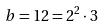<formula> <loc_0><loc_0><loc_500><loc_500>b = 1 2 = 2 ^ { 2 } \cdot 3</formula> 